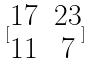Convert formula to latex. <formula><loc_0><loc_0><loc_500><loc_500>[ \begin{matrix} 1 7 & 2 3 \\ 1 1 & 7 \end{matrix} ]</formula> 